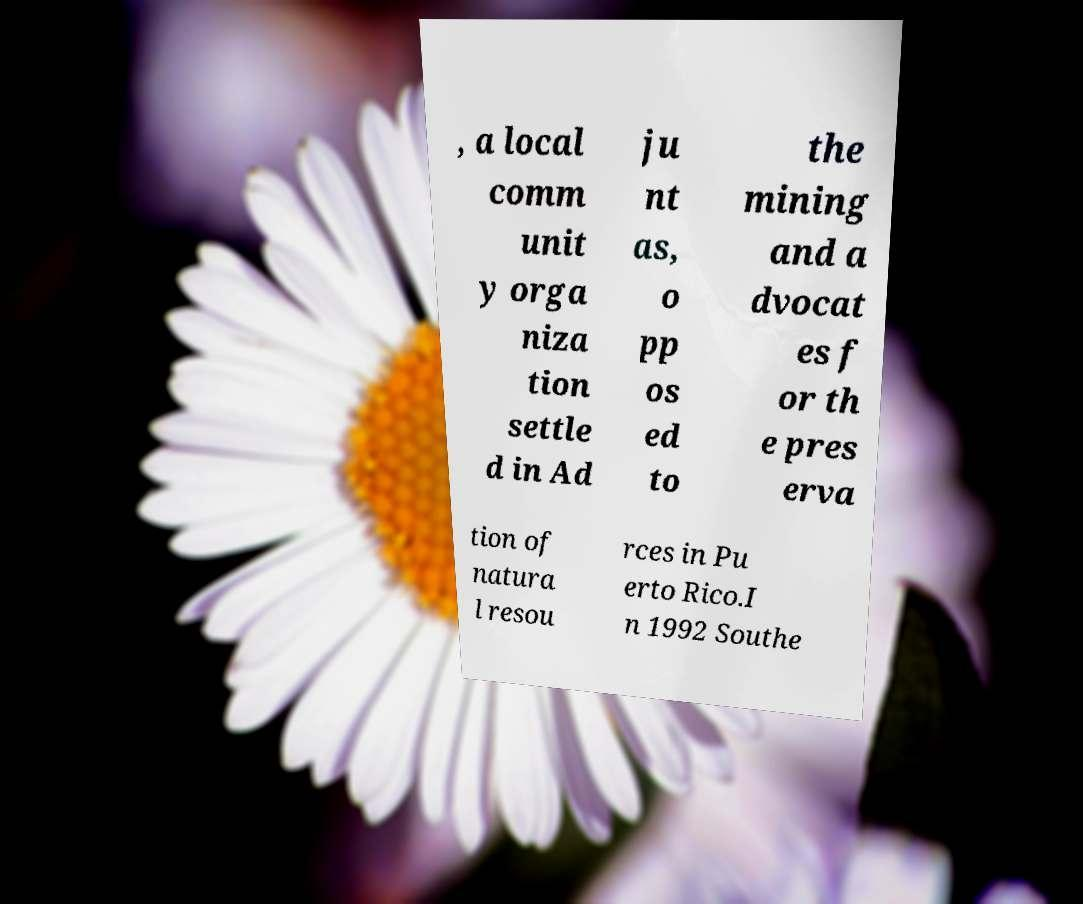Please read and relay the text visible in this image. What does it say? , a local comm unit y orga niza tion settle d in Ad ju nt as, o pp os ed to the mining and a dvocat es f or th e pres erva tion of natura l resou rces in Pu erto Rico.I n 1992 Southe 